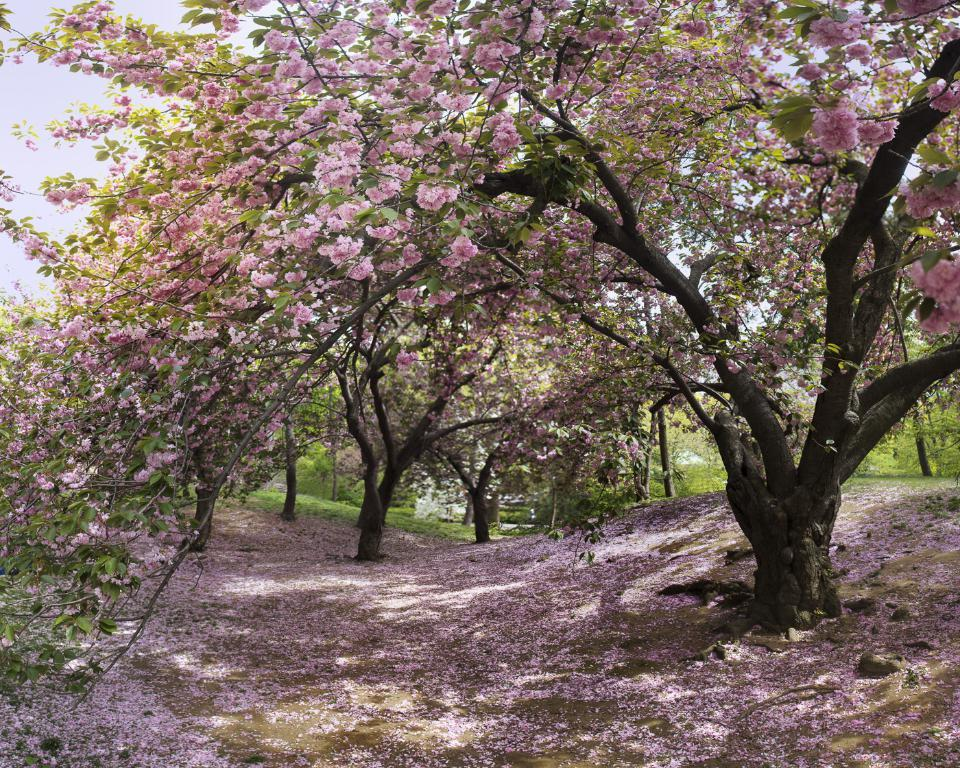What type of vegetation can be seen in the image? There are trees and grass in the image. What is visible on the ground in the image? There are flowers on the ground in the image. What color are the flowers in the image? The flowers are pink in color. What can be seen in the background of the image? The sky is visible in the background of the image. Where is the sugar located in the image? There is no sugar present in the image. What type of throne can be seen in the image? There is no throne present in the image. 